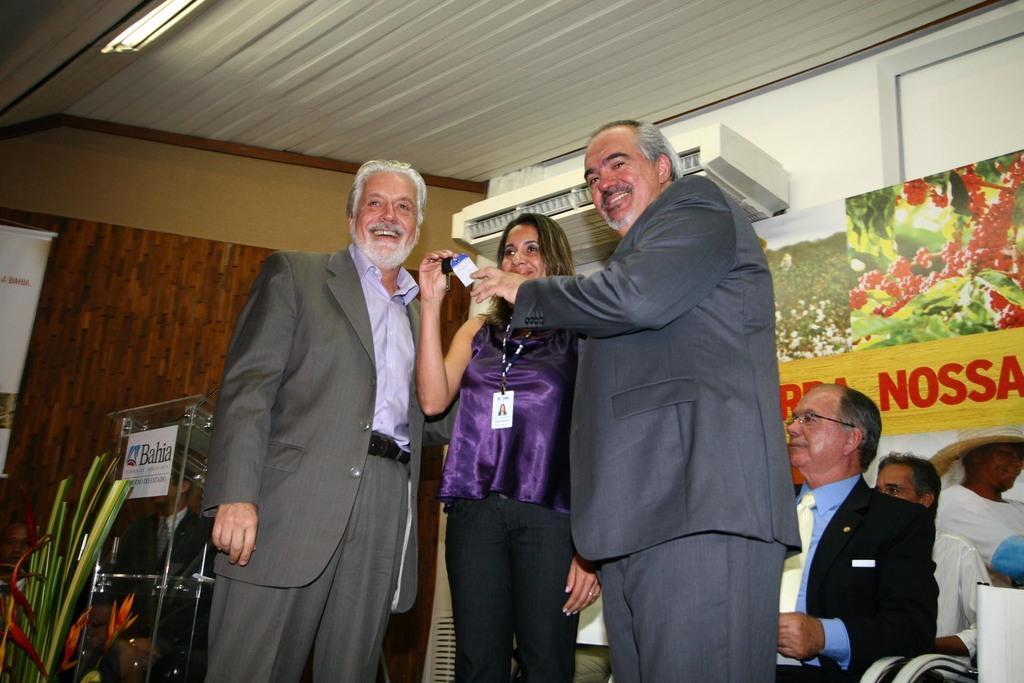How would you summarize this image in a sentence or two? In this picture we can see three persons standing and smiling, in the background there are some people sitting, there is a plant on the left side, we can see the ceiling at the top of the picture, there is a light here, we can see a board here. 